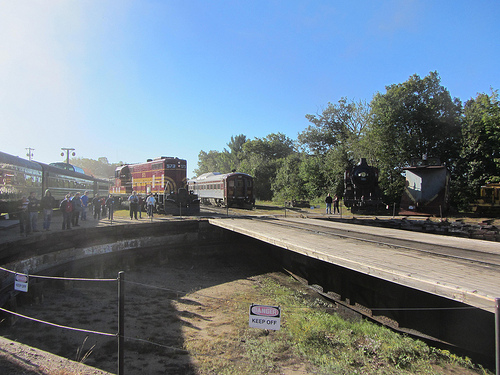Are the standing people on the platform standing near a bus? No, the standing people on the platform are not near a bus. 